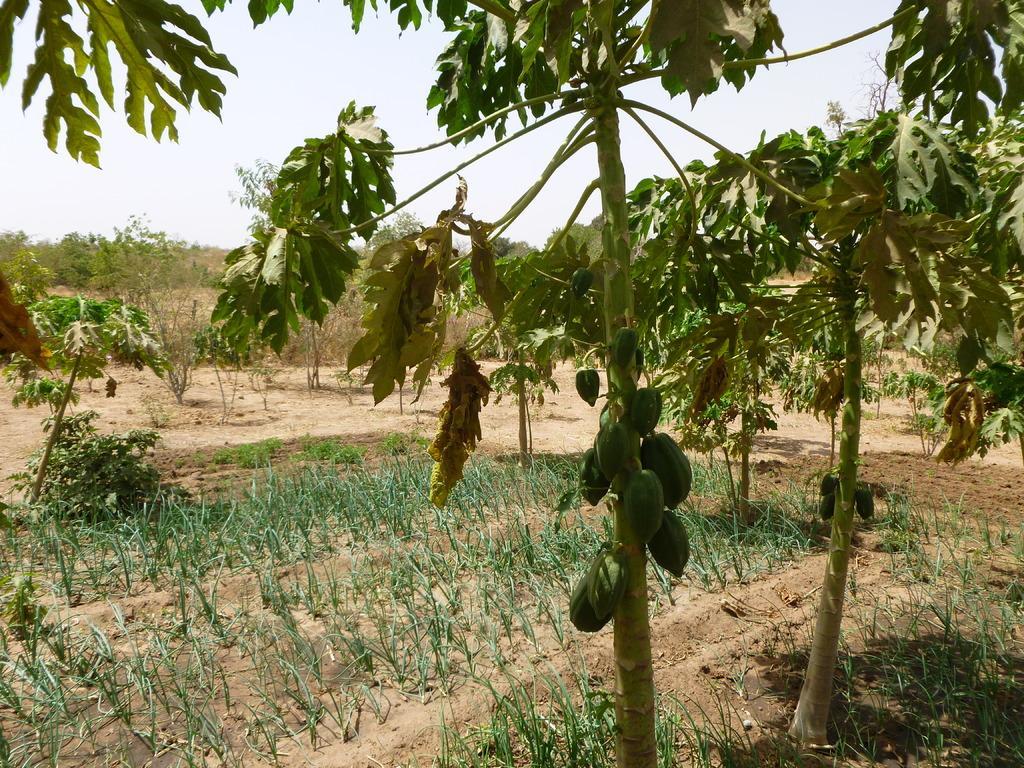Could you give a brief overview of what you see in this image? In this image we can see some plants, papayas and trees, in the background we can see the sky. 